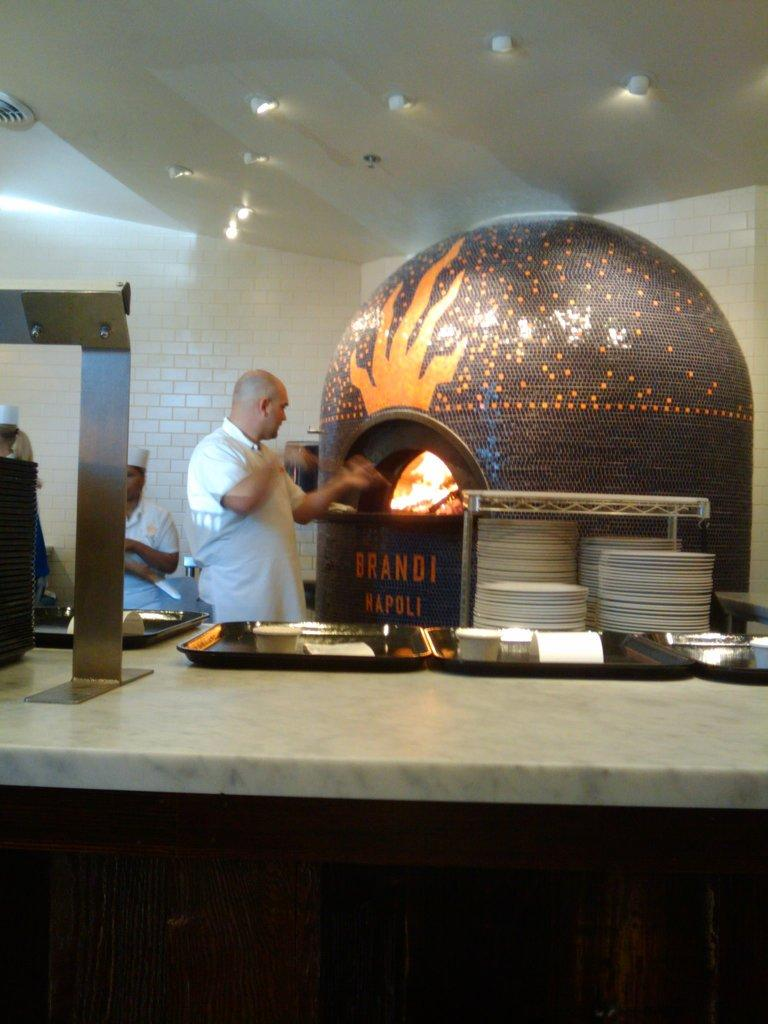<image>
Present a compact description of the photo's key features. A man is putting food into an oven at Brandi Kapoli. 